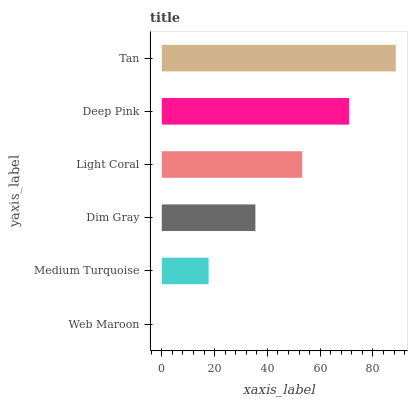Is Web Maroon the minimum?
Answer yes or no. Yes. Is Tan the maximum?
Answer yes or no. Yes. Is Medium Turquoise the minimum?
Answer yes or no. No. Is Medium Turquoise the maximum?
Answer yes or no. No. Is Medium Turquoise greater than Web Maroon?
Answer yes or no. Yes. Is Web Maroon less than Medium Turquoise?
Answer yes or no. Yes. Is Web Maroon greater than Medium Turquoise?
Answer yes or no. No. Is Medium Turquoise less than Web Maroon?
Answer yes or no. No. Is Light Coral the high median?
Answer yes or no. Yes. Is Dim Gray the low median?
Answer yes or no. Yes. Is Medium Turquoise the high median?
Answer yes or no. No. Is Medium Turquoise the low median?
Answer yes or no. No. 